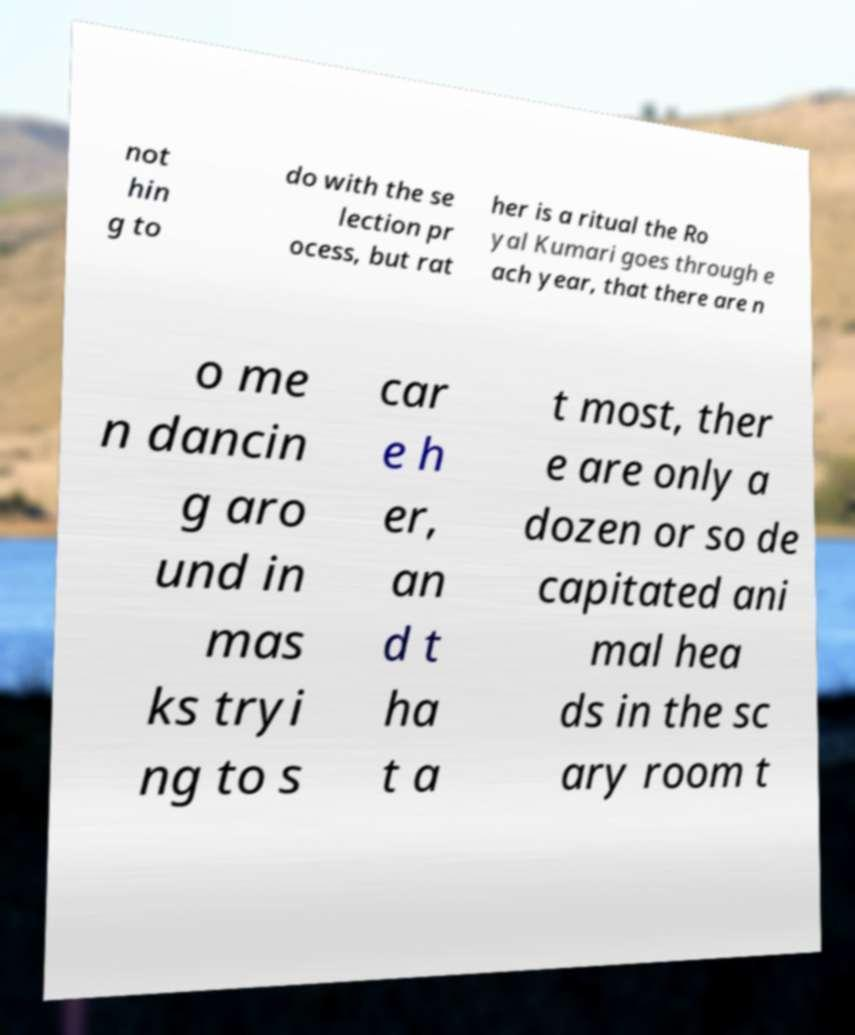There's text embedded in this image that I need extracted. Can you transcribe it verbatim? not hin g to do with the se lection pr ocess, but rat her is a ritual the Ro yal Kumari goes through e ach year, that there are n o me n dancin g aro und in mas ks tryi ng to s car e h er, an d t ha t a t most, ther e are only a dozen or so de capitated ani mal hea ds in the sc ary room t 